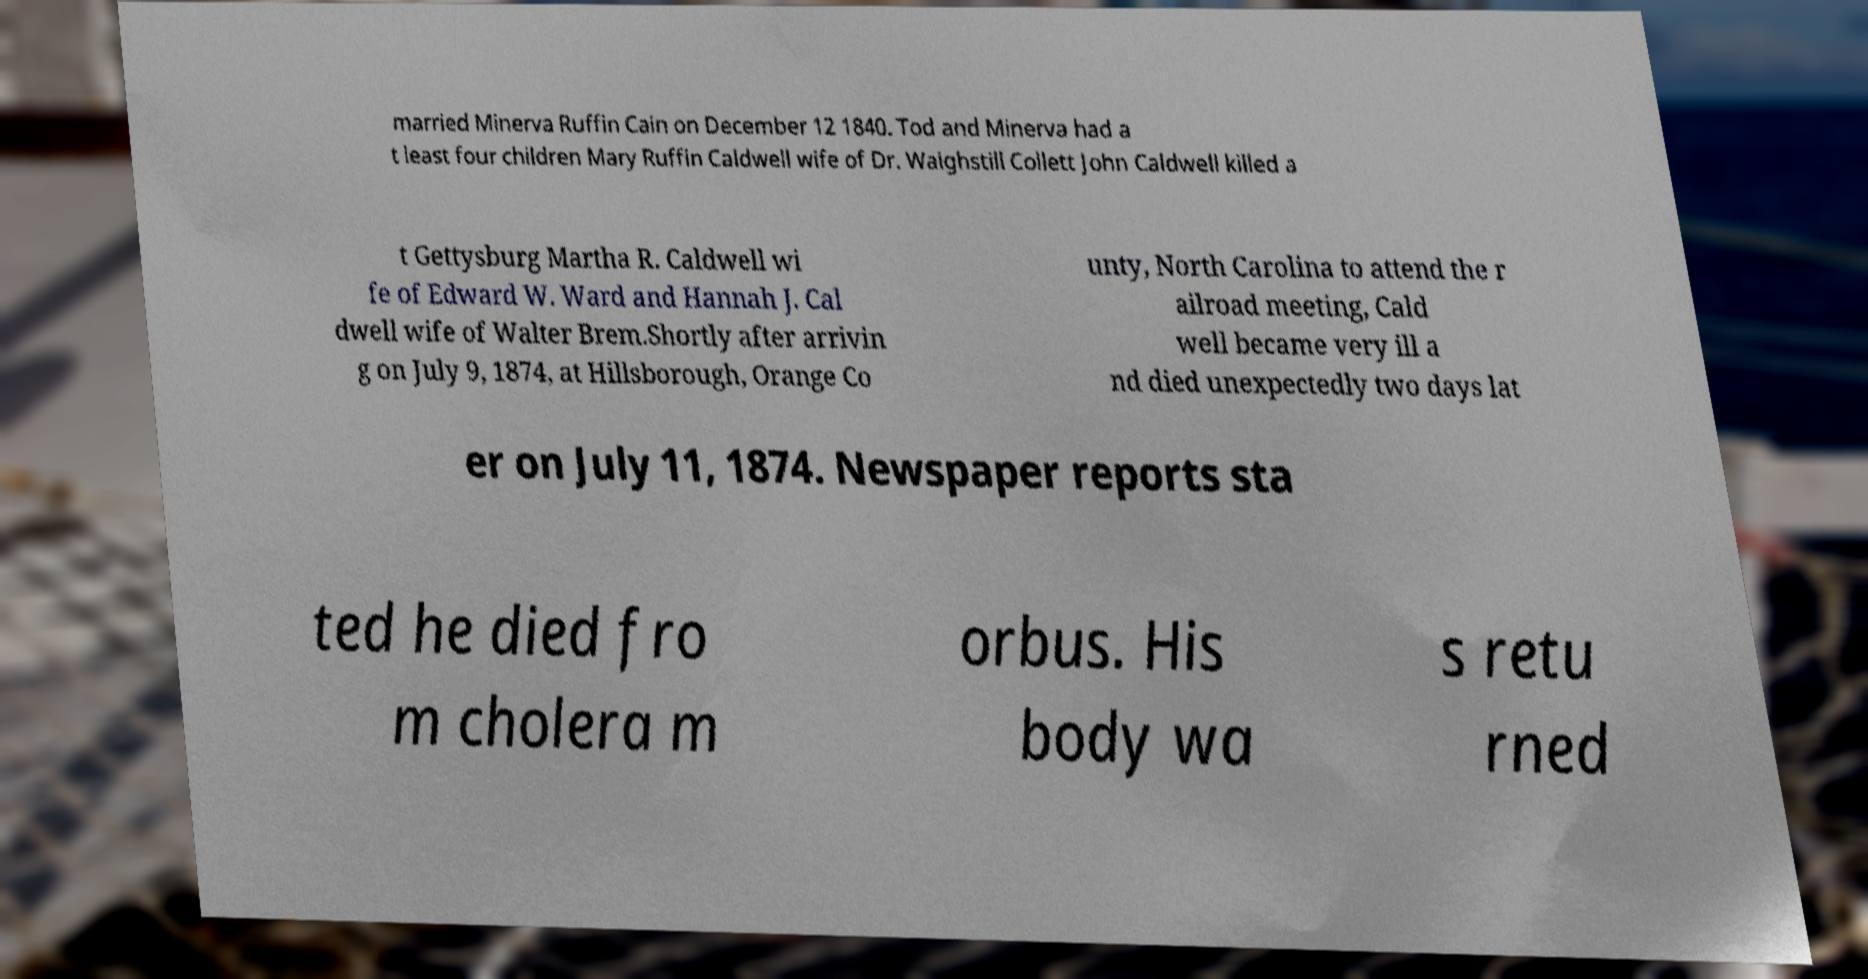Please read and relay the text visible in this image. What does it say? married Minerva Ruffin Cain on December 12 1840. Tod and Minerva had a t least four children Mary Ruffin Caldwell wife of Dr. Waighstill Collett John Caldwell killed a t Gettysburg Martha R. Caldwell wi fe of Edward W. Ward and Hannah J. Cal dwell wife of Walter Brem.Shortly after arrivin g on July 9, 1874, at Hillsborough, Orange Co unty, North Carolina to attend the r ailroad meeting, Cald well became very ill a nd died unexpectedly two days lat er on July 11, 1874. Newspaper reports sta ted he died fro m cholera m orbus. His body wa s retu rned 